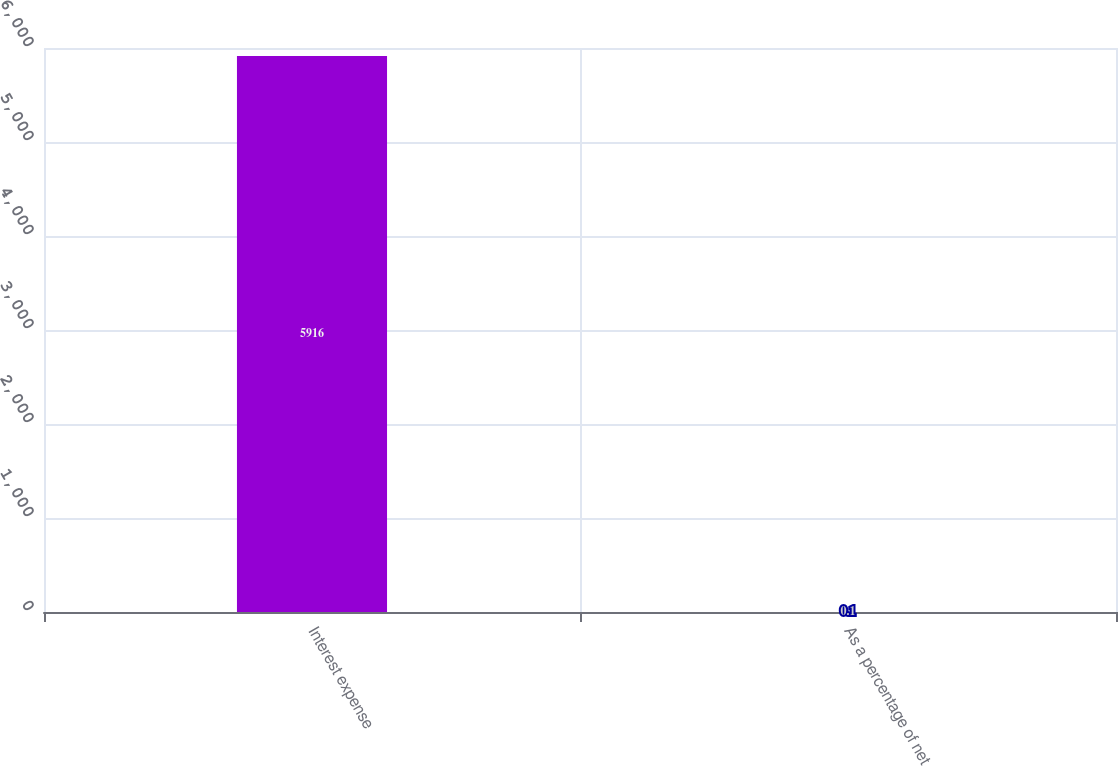Convert chart to OTSL. <chart><loc_0><loc_0><loc_500><loc_500><bar_chart><fcel>Interest expense<fcel>As a percentage of net<nl><fcel>5916<fcel>0.1<nl></chart> 